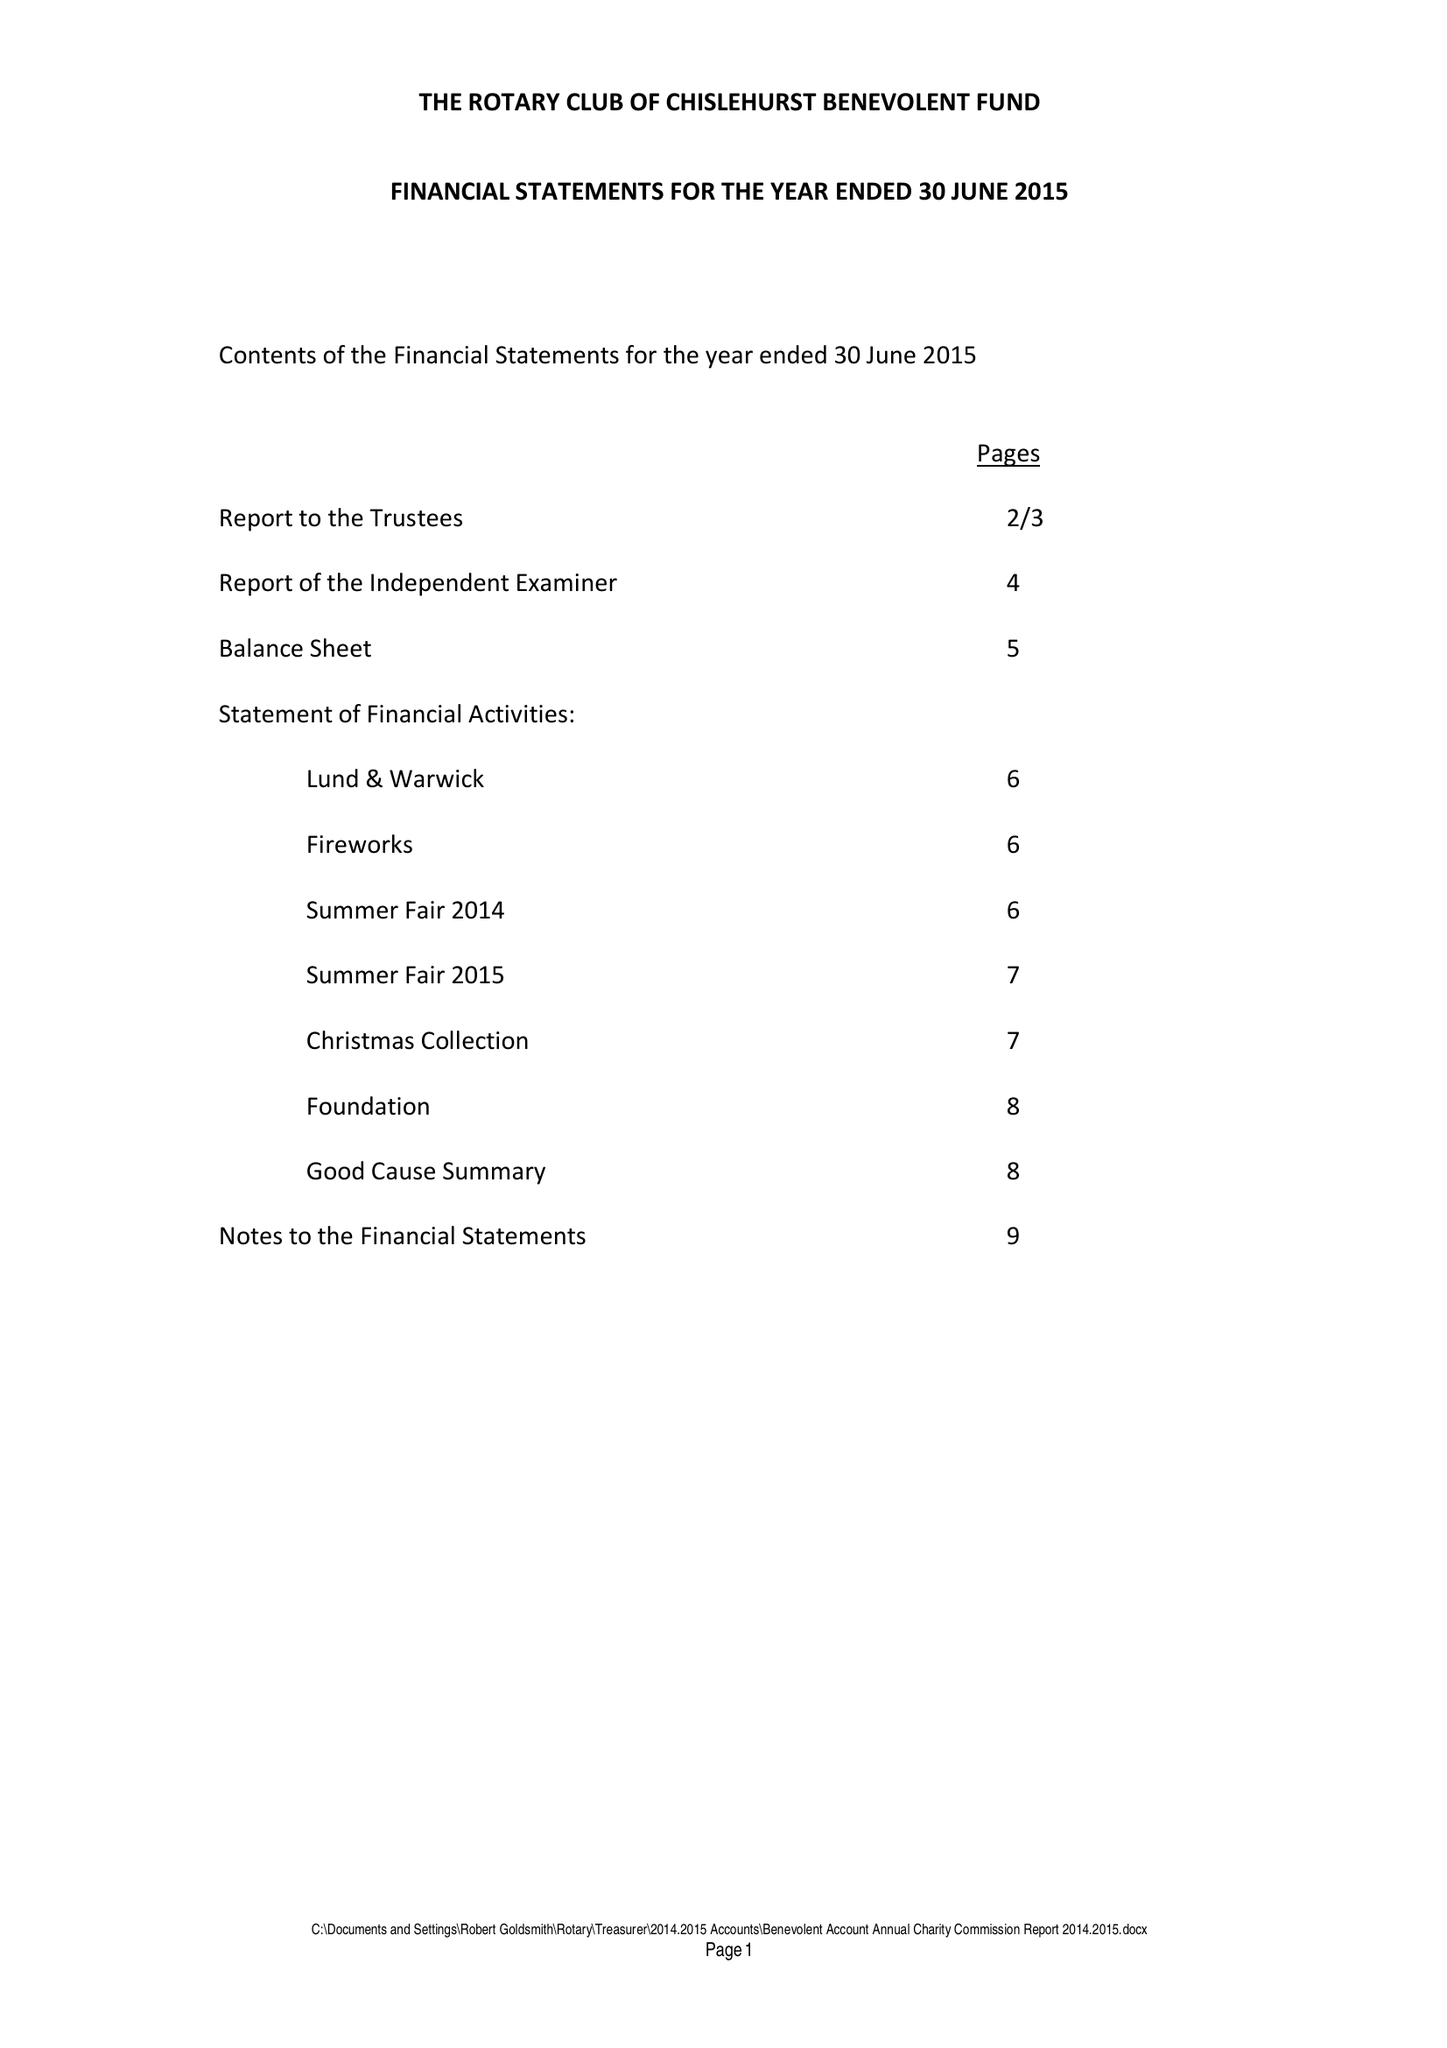What is the value for the charity_number?
Answer the question using a single word or phrase. 257747 